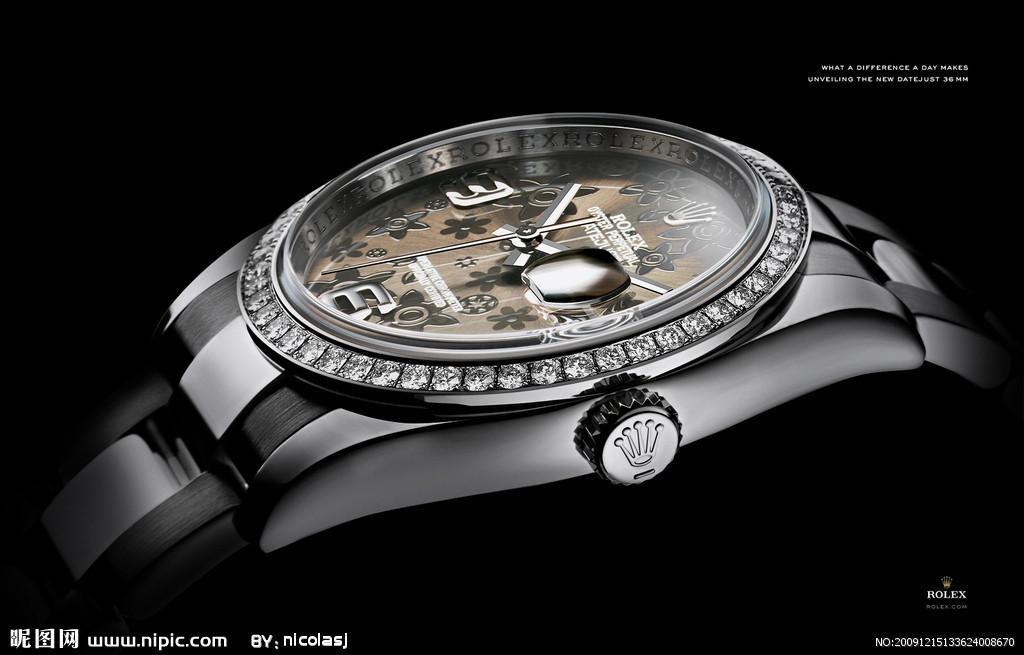Provide a one-sentence caption for the provided image. The side of a Rolex watch is lined with diamonds. 